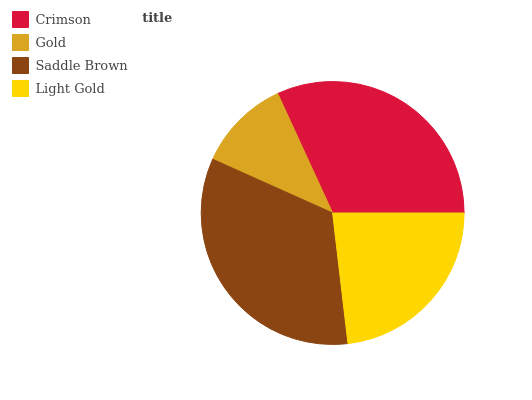Is Gold the minimum?
Answer yes or no. Yes. Is Saddle Brown the maximum?
Answer yes or no. Yes. Is Saddle Brown the minimum?
Answer yes or no. No. Is Gold the maximum?
Answer yes or no. No. Is Saddle Brown greater than Gold?
Answer yes or no. Yes. Is Gold less than Saddle Brown?
Answer yes or no. Yes. Is Gold greater than Saddle Brown?
Answer yes or no. No. Is Saddle Brown less than Gold?
Answer yes or no. No. Is Crimson the high median?
Answer yes or no. Yes. Is Light Gold the low median?
Answer yes or no. Yes. Is Light Gold the high median?
Answer yes or no. No. Is Gold the low median?
Answer yes or no. No. 